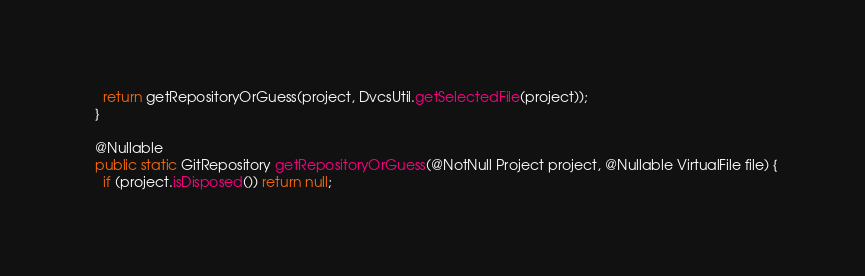<code> <loc_0><loc_0><loc_500><loc_500><_Java_>    return getRepositoryOrGuess(project, DvcsUtil.getSelectedFile(project));
  }

  @Nullable
  public static GitRepository getRepositoryOrGuess(@NotNull Project project, @Nullable VirtualFile file) {
    if (project.isDisposed()) return null;</code> 